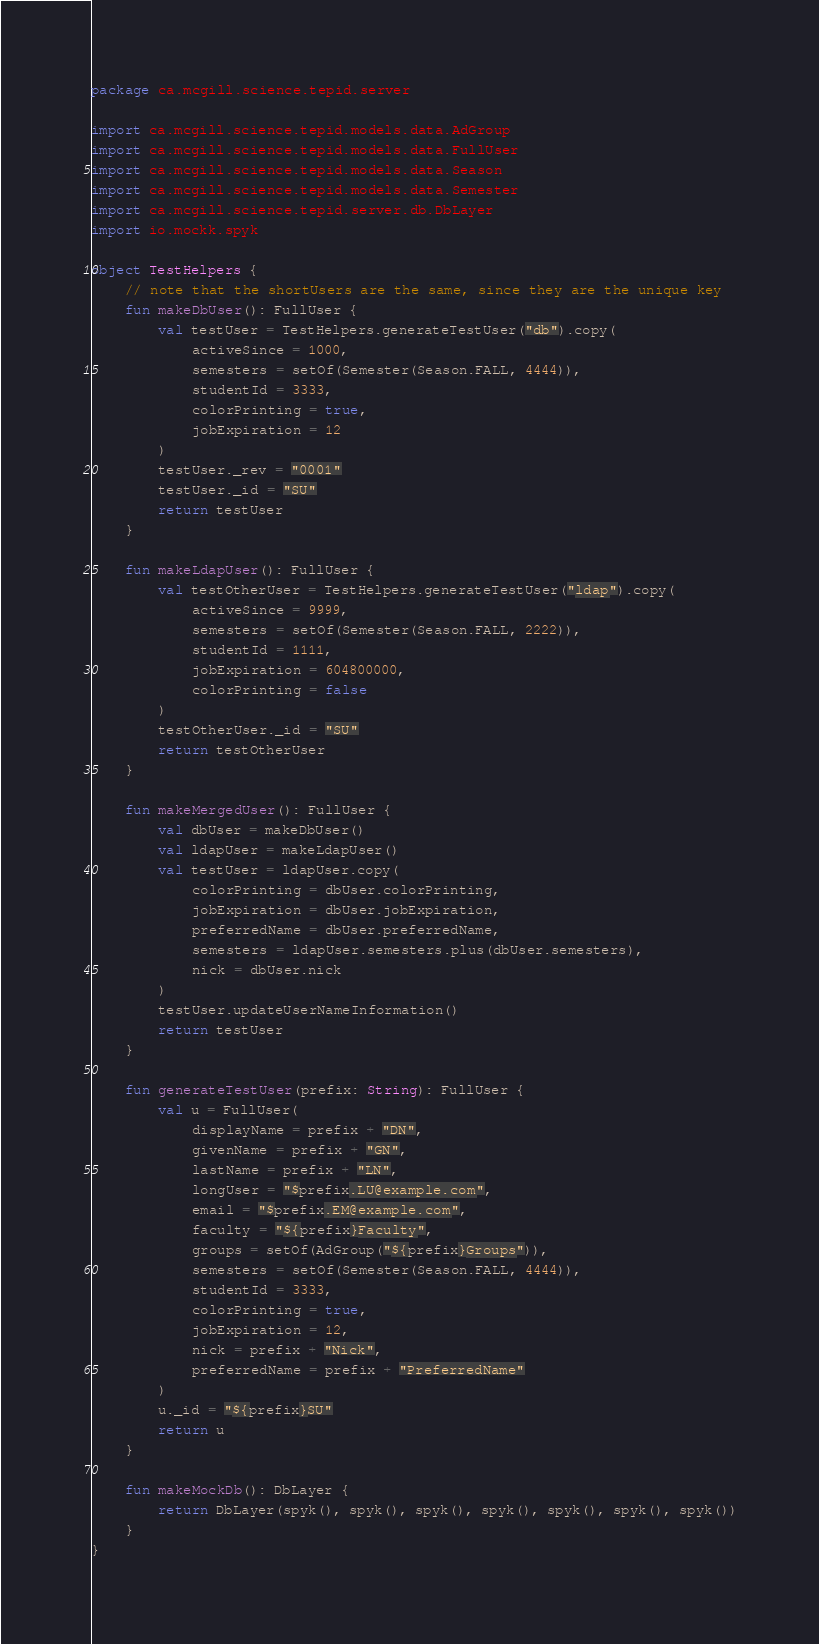<code> <loc_0><loc_0><loc_500><loc_500><_Kotlin_>package ca.mcgill.science.tepid.server

import ca.mcgill.science.tepid.models.data.AdGroup
import ca.mcgill.science.tepid.models.data.FullUser
import ca.mcgill.science.tepid.models.data.Season
import ca.mcgill.science.tepid.models.data.Semester
import ca.mcgill.science.tepid.server.db.DbLayer
import io.mockk.spyk

object TestHelpers {
    // note that the shortUsers are the same, since they are the unique key
    fun makeDbUser(): FullUser {
        val testUser = TestHelpers.generateTestUser("db").copy(
            activeSince = 1000,
            semesters = setOf(Semester(Season.FALL, 4444)),
            studentId = 3333,
            colorPrinting = true,
            jobExpiration = 12
        )
        testUser._rev = "0001"
        testUser._id = "SU"
        return testUser
    }

    fun makeLdapUser(): FullUser {
        val testOtherUser = TestHelpers.generateTestUser("ldap").copy(
            activeSince = 9999,
            semesters = setOf(Semester(Season.FALL, 2222)),
            studentId = 1111,
            jobExpiration = 604800000,
            colorPrinting = false
        )
        testOtherUser._id = "SU"
        return testOtherUser
    }

    fun makeMergedUser(): FullUser {
        val dbUser = makeDbUser()
        val ldapUser = makeLdapUser()
        val testUser = ldapUser.copy(
            colorPrinting = dbUser.colorPrinting,
            jobExpiration = dbUser.jobExpiration,
            preferredName = dbUser.preferredName,
            semesters = ldapUser.semesters.plus(dbUser.semesters),
            nick = dbUser.nick
        )
        testUser.updateUserNameInformation()
        return testUser
    }

    fun generateTestUser(prefix: String): FullUser {
        val u = FullUser(
            displayName = prefix + "DN",
            givenName = prefix + "GN",
            lastName = prefix + "LN",
            longUser = "$prefix.LU@example.com",
            email = "$prefix.EM@example.com",
            faculty = "${prefix}Faculty",
            groups = setOf(AdGroup("${prefix}Groups")),
            semesters = setOf(Semester(Season.FALL, 4444)),
            studentId = 3333,
            colorPrinting = true,
            jobExpiration = 12,
            nick = prefix + "Nick",
            preferredName = prefix + "PreferredName"
        )
        u._id = "${prefix}SU"
        return u
    }

    fun makeMockDb(): DbLayer {
        return DbLayer(spyk(), spyk(), spyk(), spyk(), spyk(), spyk(), spyk())
    }
}</code> 